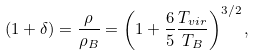<formula> <loc_0><loc_0><loc_500><loc_500>\left ( 1 + \delta \right ) = \frac { \rho } { \rho _ { B } } = \left ( 1 + \frac { 6 } { 5 } \frac { T _ { v i r } } { T _ { B } } \right ) ^ { 3 / 2 } ,</formula> 